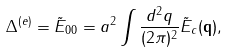Convert formula to latex. <formula><loc_0><loc_0><loc_500><loc_500>\Delta ^ { ( e ) } = \tilde { E } _ { 0 0 } = a ^ { 2 } \int \frac { d ^ { 2 } q } { ( 2 \pi ) ^ { 2 } } \tilde { E } _ { c } ( \mathbf q ) ,</formula> 